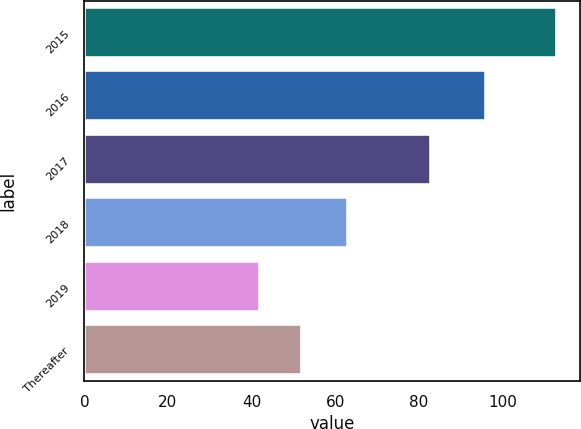<chart> <loc_0><loc_0><loc_500><loc_500><bar_chart><fcel>2015<fcel>2016<fcel>2017<fcel>2018<fcel>2019<fcel>Thereafter<nl><fcel>113<fcel>96<fcel>83<fcel>63<fcel>42<fcel>52<nl></chart> 